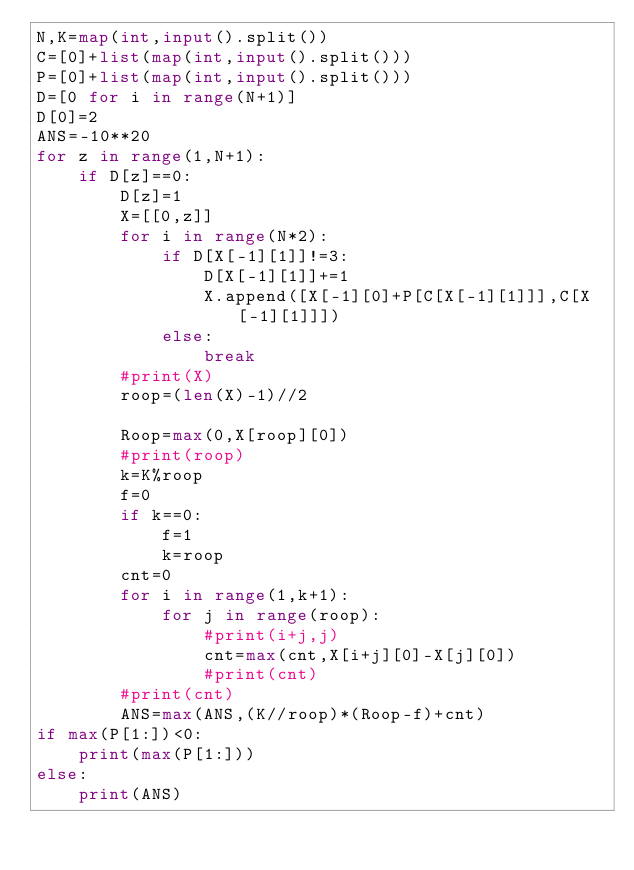<code> <loc_0><loc_0><loc_500><loc_500><_Python_>N,K=map(int,input().split())
C=[0]+list(map(int,input().split()))
P=[0]+list(map(int,input().split()))
D=[0 for i in range(N+1)]
D[0]=2
ANS=-10**20
for z in range(1,N+1):
    if D[z]==0:
        D[z]=1
        X=[[0,z]]
        for i in range(N*2):
            if D[X[-1][1]]!=3:
                D[X[-1][1]]+=1
                X.append([X[-1][0]+P[C[X[-1][1]]],C[X[-1][1]]])
            else:
                break
        #print(X)
        roop=(len(X)-1)//2
        
        Roop=max(0,X[roop][0])
        #print(roop)
        k=K%roop
        f=0
        if k==0:
            f=1
            k=roop
        cnt=0
        for i in range(1,k+1):
            for j in range(roop):
                #print(i+j,j)
                cnt=max(cnt,X[i+j][0]-X[j][0])
                #print(cnt)
        #print(cnt)
        ANS=max(ANS,(K//roop)*(Roop-f)+cnt)
if max(P[1:])<0:
    print(max(P[1:]))
else:
    print(ANS)</code> 